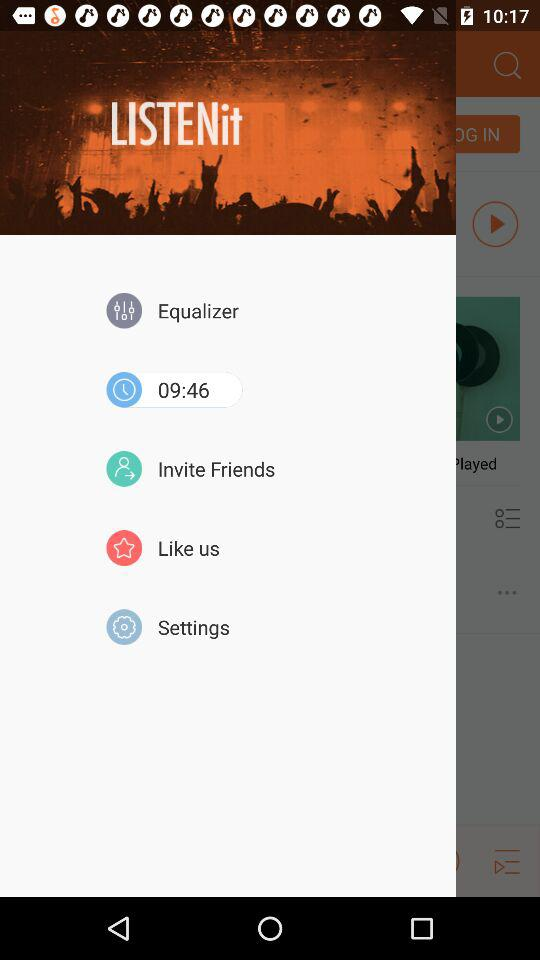What is the time shown on the screen? The time shown on the screen is 09:46. 